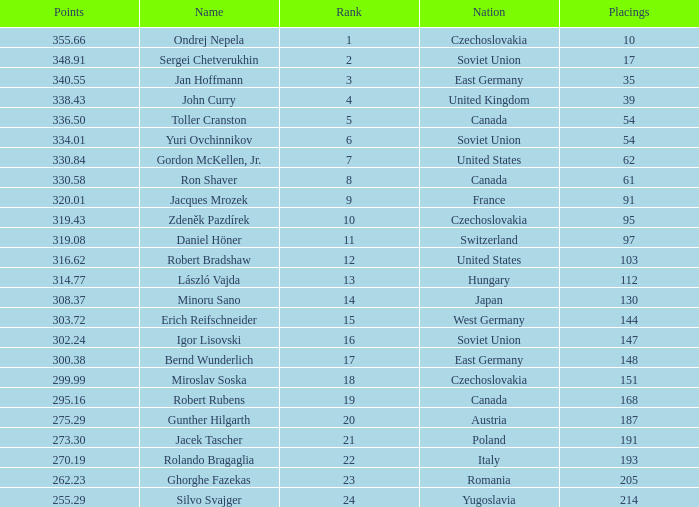Which Placings have a Nation of west germany, and Points larger than 303.72? None. I'm looking to parse the entire table for insights. Could you assist me with that? {'header': ['Points', 'Name', 'Rank', 'Nation', 'Placings'], 'rows': [['355.66', 'Ondrej Nepela', '1', 'Czechoslovakia', '10'], ['348.91', 'Sergei Chetverukhin', '2', 'Soviet Union', '17'], ['340.55', 'Jan Hoffmann', '3', 'East Germany', '35'], ['338.43', 'John Curry', '4', 'United Kingdom', '39'], ['336.50', 'Toller Cranston', '5', 'Canada', '54'], ['334.01', 'Yuri Ovchinnikov', '6', 'Soviet Union', '54'], ['330.84', 'Gordon McKellen, Jr.', '7', 'United States', '62'], ['330.58', 'Ron Shaver', '8', 'Canada', '61'], ['320.01', 'Jacques Mrozek', '9', 'France', '91'], ['319.43', 'Zdeněk Pazdírek', '10', 'Czechoslovakia', '95'], ['319.08', 'Daniel Höner', '11', 'Switzerland', '97'], ['316.62', 'Robert Bradshaw', '12', 'United States', '103'], ['314.77', 'László Vajda', '13', 'Hungary', '112'], ['308.37', 'Minoru Sano', '14', 'Japan', '130'], ['303.72', 'Erich Reifschneider', '15', 'West Germany', '144'], ['302.24', 'Igor Lisovski', '16', 'Soviet Union', '147'], ['300.38', 'Bernd Wunderlich', '17', 'East Germany', '148'], ['299.99', 'Miroslav Soska', '18', 'Czechoslovakia', '151'], ['295.16', 'Robert Rubens', '19', 'Canada', '168'], ['275.29', 'Gunther Hilgarth', '20', 'Austria', '187'], ['273.30', 'Jacek Tascher', '21', 'Poland', '191'], ['270.19', 'Rolando Bragaglia', '22', 'Italy', '193'], ['262.23', 'Ghorghe Fazekas', '23', 'Romania', '205'], ['255.29', 'Silvo Svajger', '24', 'Yugoslavia', '214']]} 